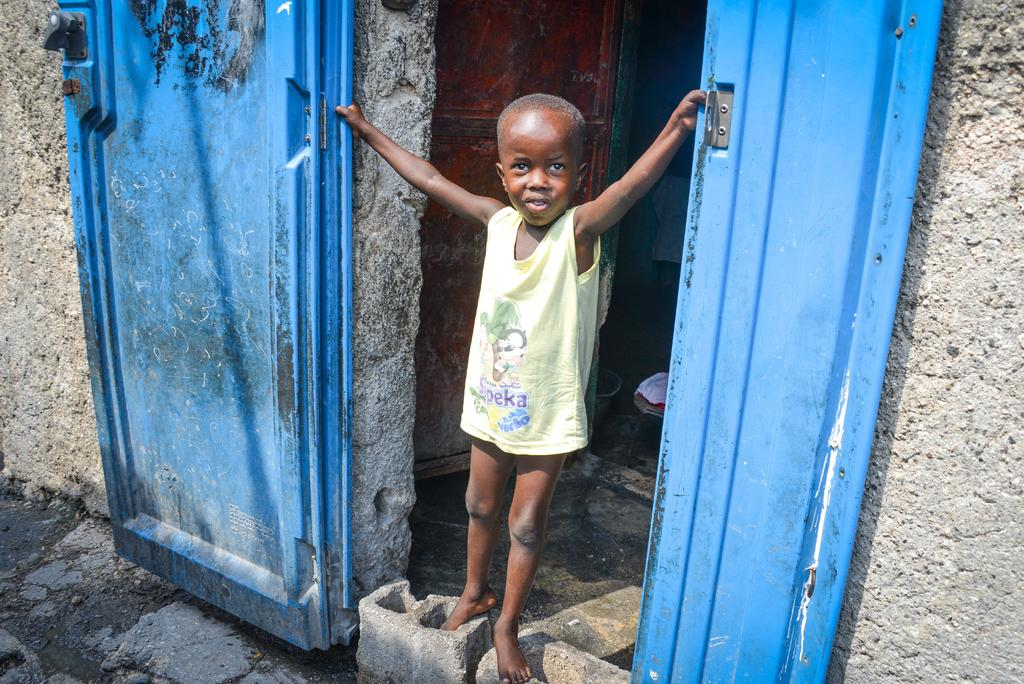What is the main subject of the image? The main subject of the image is a kid. What is the kid wearing in the image? The kid is wearing a yellow vest in the image. Where is the kid positioned in the image? The kid is standing between two doors in the image. What type of knowledge can be seen in the kid's foot in the image? There is no knowledge or any reference to knowledge in the kid's foot in the image. 